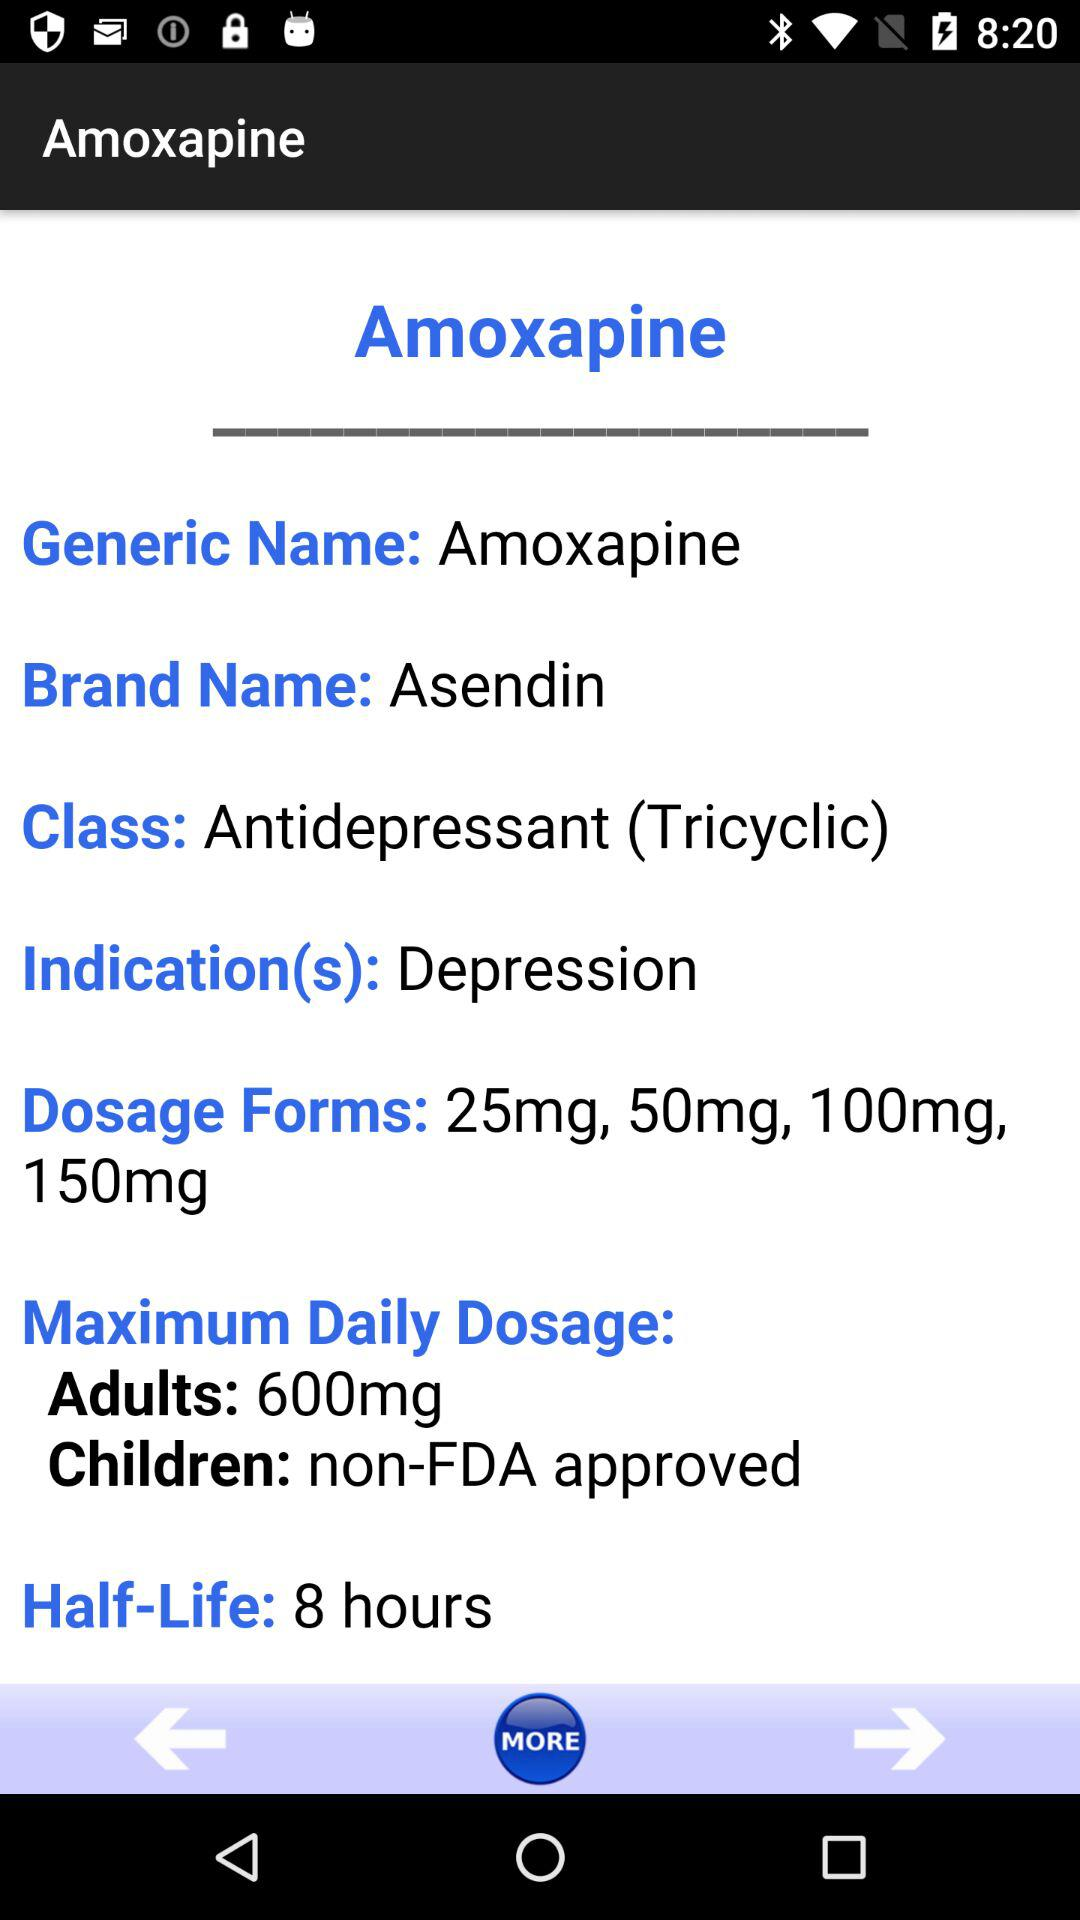How many hours is the half-life of Amoxapine?
Answer the question using a single word or phrase. 8 hours 